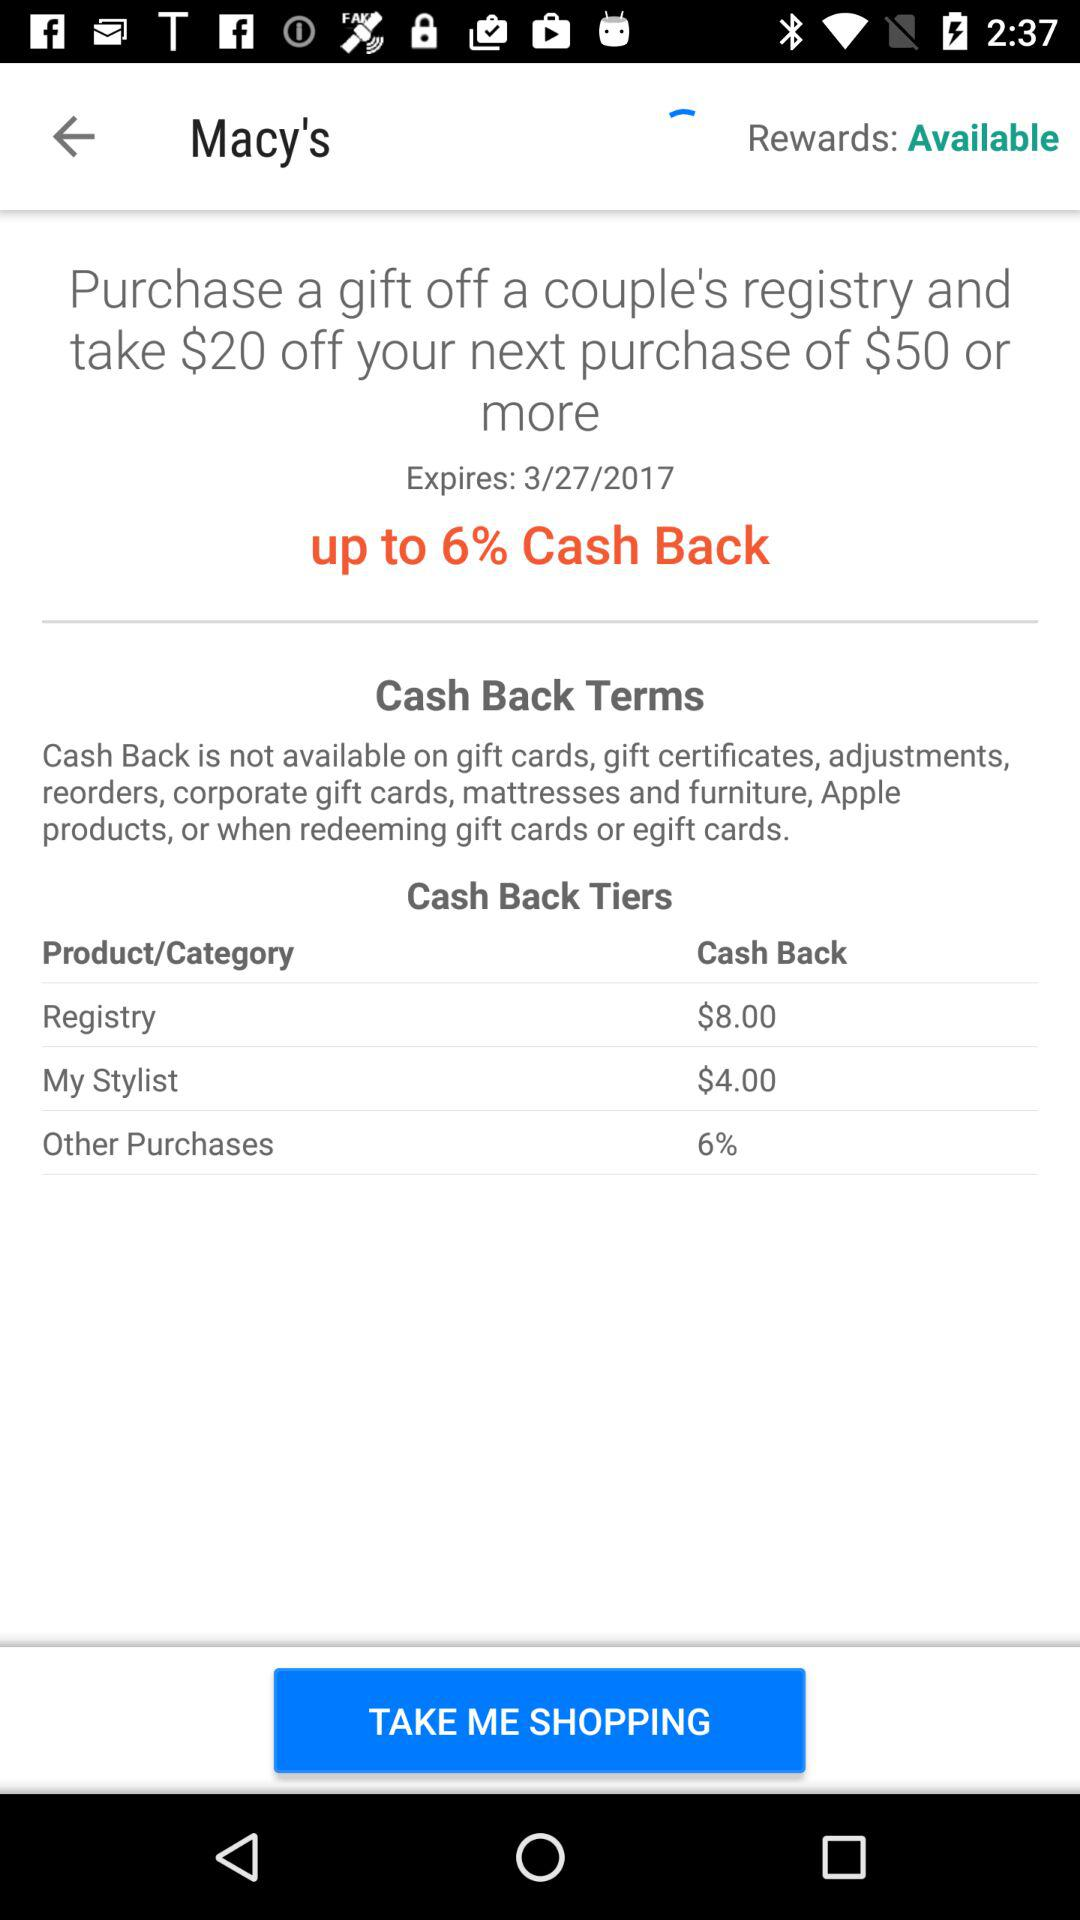How much cashback will we get in "My Stylist"? You will get $4.00 cashback in "My Stylist". 